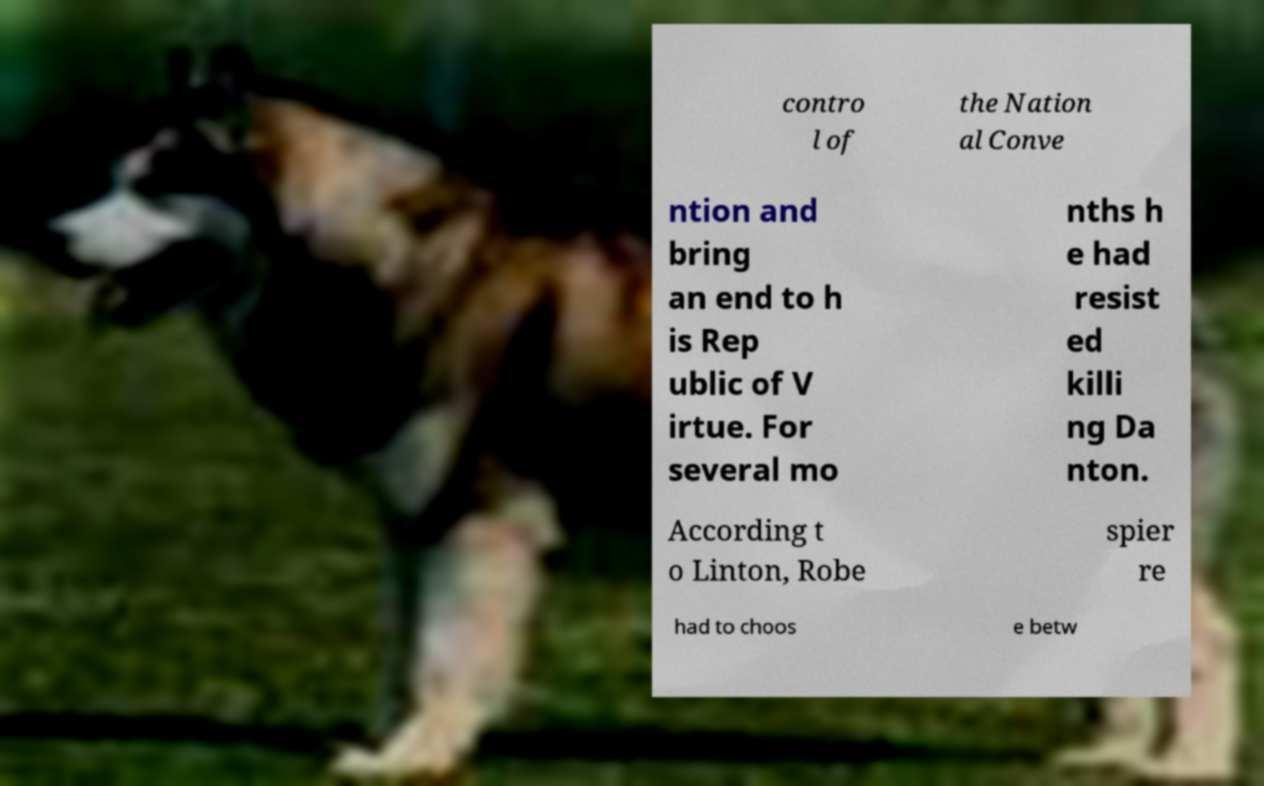There's text embedded in this image that I need extracted. Can you transcribe it verbatim? contro l of the Nation al Conve ntion and bring an end to h is Rep ublic of V irtue. For several mo nths h e had resist ed killi ng Da nton. According t o Linton, Robe spier re had to choos e betw 